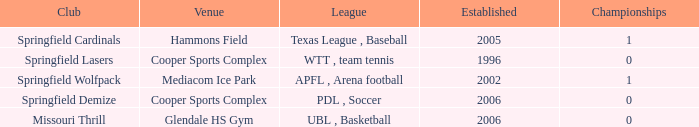What are the highest championships where the club is Springfield Cardinals? 1.0. 